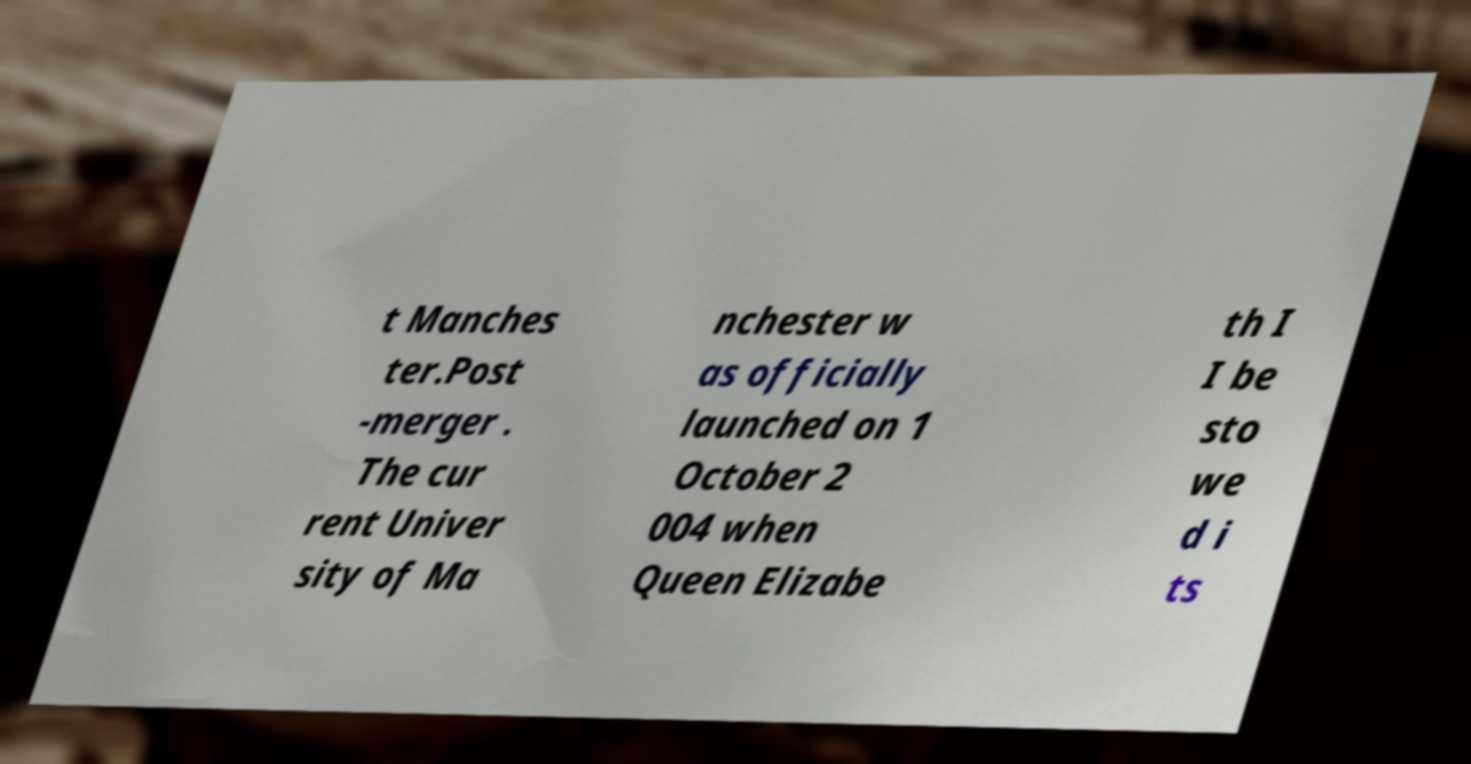For documentation purposes, I need the text within this image transcribed. Could you provide that? t Manches ter.Post -merger . The cur rent Univer sity of Ma nchester w as officially launched on 1 October 2 004 when Queen Elizabe th I I be sto we d i ts 